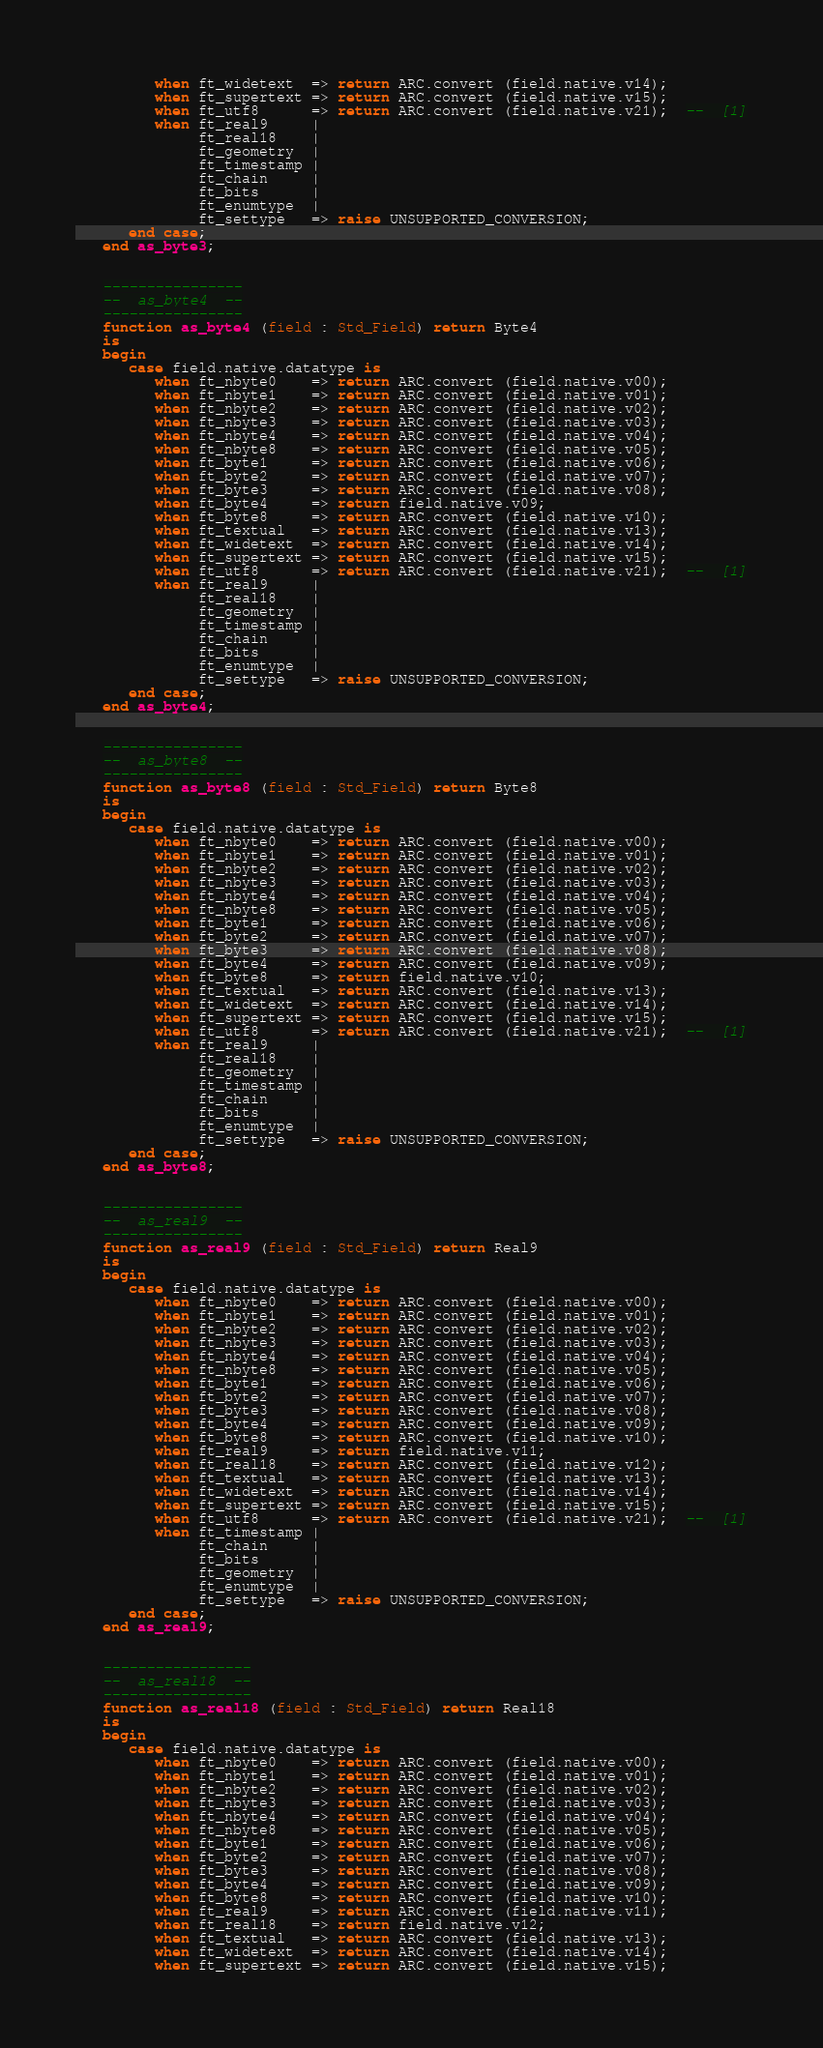Convert code to text. <code><loc_0><loc_0><loc_500><loc_500><_Ada_>         when ft_widetext  => return ARC.convert (field.native.v14);
         when ft_supertext => return ARC.convert (field.native.v15);
         when ft_utf8      => return ARC.convert (field.native.v21);  --  [1]
         when ft_real9     |
              ft_real18    |
              ft_geometry  |
              ft_timestamp |
              ft_chain     |
              ft_bits      |
              ft_enumtype  |
              ft_settype   => raise UNSUPPORTED_CONVERSION;
      end case;
   end as_byte3;


   ----------------
   --  as_byte4  --
   ----------------
   function as_byte4 (field : Std_Field) return Byte4
   is
   begin
      case field.native.datatype is
         when ft_nbyte0    => return ARC.convert (field.native.v00);
         when ft_nbyte1    => return ARC.convert (field.native.v01);
         when ft_nbyte2    => return ARC.convert (field.native.v02);
         when ft_nbyte3    => return ARC.convert (field.native.v03);
         when ft_nbyte4    => return ARC.convert (field.native.v04);
         when ft_nbyte8    => return ARC.convert (field.native.v05);
         when ft_byte1     => return ARC.convert (field.native.v06);
         when ft_byte2     => return ARC.convert (field.native.v07);
         when ft_byte3     => return ARC.convert (field.native.v08);
         when ft_byte4     => return field.native.v09;
         when ft_byte8     => return ARC.convert (field.native.v10);
         when ft_textual   => return ARC.convert (field.native.v13);
         when ft_widetext  => return ARC.convert (field.native.v14);
         when ft_supertext => return ARC.convert (field.native.v15);
         when ft_utf8      => return ARC.convert (field.native.v21);  --  [1]
         when ft_real9     |
              ft_real18    |
              ft_geometry  |
              ft_timestamp |
              ft_chain     |
              ft_bits      |
              ft_enumtype  |
              ft_settype   => raise UNSUPPORTED_CONVERSION;
      end case;
   end as_byte4;


   ----------------
   --  as_byte8  --
   ----------------
   function as_byte8 (field : Std_Field) return Byte8
   is
   begin
      case field.native.datatype is
         when ft_nbyte0    => return ARC.convert (field.native.v00);
         when ft_nbyte1    => return ARC.convert (field.native.v01);
         when ft_nbyte2    => return ARC.convert (field.native.v02);
         when ft_nbyte3    => return ARC.convert (field.native.v03);
         when ft_nbyte4    => return ARC.convert (field.native.v04);
         when ft_nbyte8    => return ARC.convert (field.native.v05);
         when ft_byte1     => return ARC.convert (field.native.v06);
         when ft_byte2     => return ARC.convert (field.native.v07);
         when ft_byte3     => return ARC.convert (field.native.v08);
         when ft_byte4     => return ARC.convert (field.native.v09);
         when ft_byte8     => return field.native.v10;
         when ft_textual   => return ARC.convert (field.native.v13);
         when ft_widetext  => return ARC.convert (field.native.v14);
         when ft_supertext => return ARC.convert (field.native.v15);
         when ft_utf8      => return ARC.convert (field.native.v21);  --  [1]
         when ft_real9     |
              ft_real18    |
              ft_geometry  |
              ft_timestamp |
              ft_chain     |
              ft_bits      |
              ft_enumtype  |
              ft_settype   => raise UNSUPPORTED_CONVERSION;
      end case;
   end as_byte8;


   ----------------
   --  as_real9  --
   ----------------
   function as_real9 (field : Std_Field) return Real9
   is
   begin
      case field.native.datatype is
         when ft_nbyte0    => return ARC.convert (field.native.v00);
         when ft_nbyte1    => return ARC.convert (field.native.v01);
         when ft_nbyte2    => return ARC.convert (field.native.v02);
         when ft_nbyte3    => return ARC.convert (field.native.v03);
         when ft_nbyte4    => return ARC.convert (field.native.v04);
         when ft_nbyte8    => return ARC.convert (field.native.v05);
         when ft_byte1     => return ARC.convert (field.native.v06);
         when ft_byte2     => return ARC.convert (field.native.v07);
         when ft_byte3     => return ARC.convert (field.native.v08);
         when ft_byte4     => return ARC.convert (field.native.v09);
         when ft_byte8     => return ARC.convert (field.native.v10);
         when ft_real9     => return field.native.v11;
         when ft_real18    => return ARC.convert (field.native.v12);
         when ft_textual   => return ARC.convert (field.native.v13);
         when ft_widetext  => return ARC.convert (field.native.v14);
         when ft_supertext => return ARC.convert (field.native.v15);
         when ft_utf8      => return ARC.convert (field.native.v21);  --  [1]
         when ft_timestamp |
              ft_chain     |
              ft_bits      |
              ft_geometry  |
              ft_enumtype  |
              ft_settype   => raise UNSUPPORTED_CONVERSION;
      end case;
   end as_real9;


   -----------------
   --  as_real18  --
   -----------------
   function as_real18 (field : Std_Field) return Real18
   is
   begin
      case field.native.datatype is
         when ft_nbyte0    => return ARC.convert (field.native.v00);
         when ft_nbyte1    => return ARC.convert (field.native.v01);
         when ft_nbyte2    => return ARC.convert (field.native.v02);
         when ft_nbyte3    => return ARC.convert (field.native.v03);
         when ft_nbyte4    => return ARC.convert (field.native.v04);
         when ft_nbyte8    => return ARC.convert (field.native.v05);
         when ft_byte1     => return ARC.convert (field.native.v06);
         when ft_byte2     => return ARC.convert (field.native.v07);
         when ft_byte3     => return ARC.convert (field.native.v08);
         when ft_byte4     => return ARC.convert (field.native.v09);
         when ft_byte8     => return ARC.convert (field.native.v10);
         when ft_real9     => return ARC.convert (field.native.v11);
         when ft_real18    => return field.native.v12;
         when ft_textual   => return ARC.convert (field.native.v13);
         when ft_widetext  => return ARC.convert (field.native.v14);
         when ft_supertext => return ARC.convert (field.native.v15);</code> 